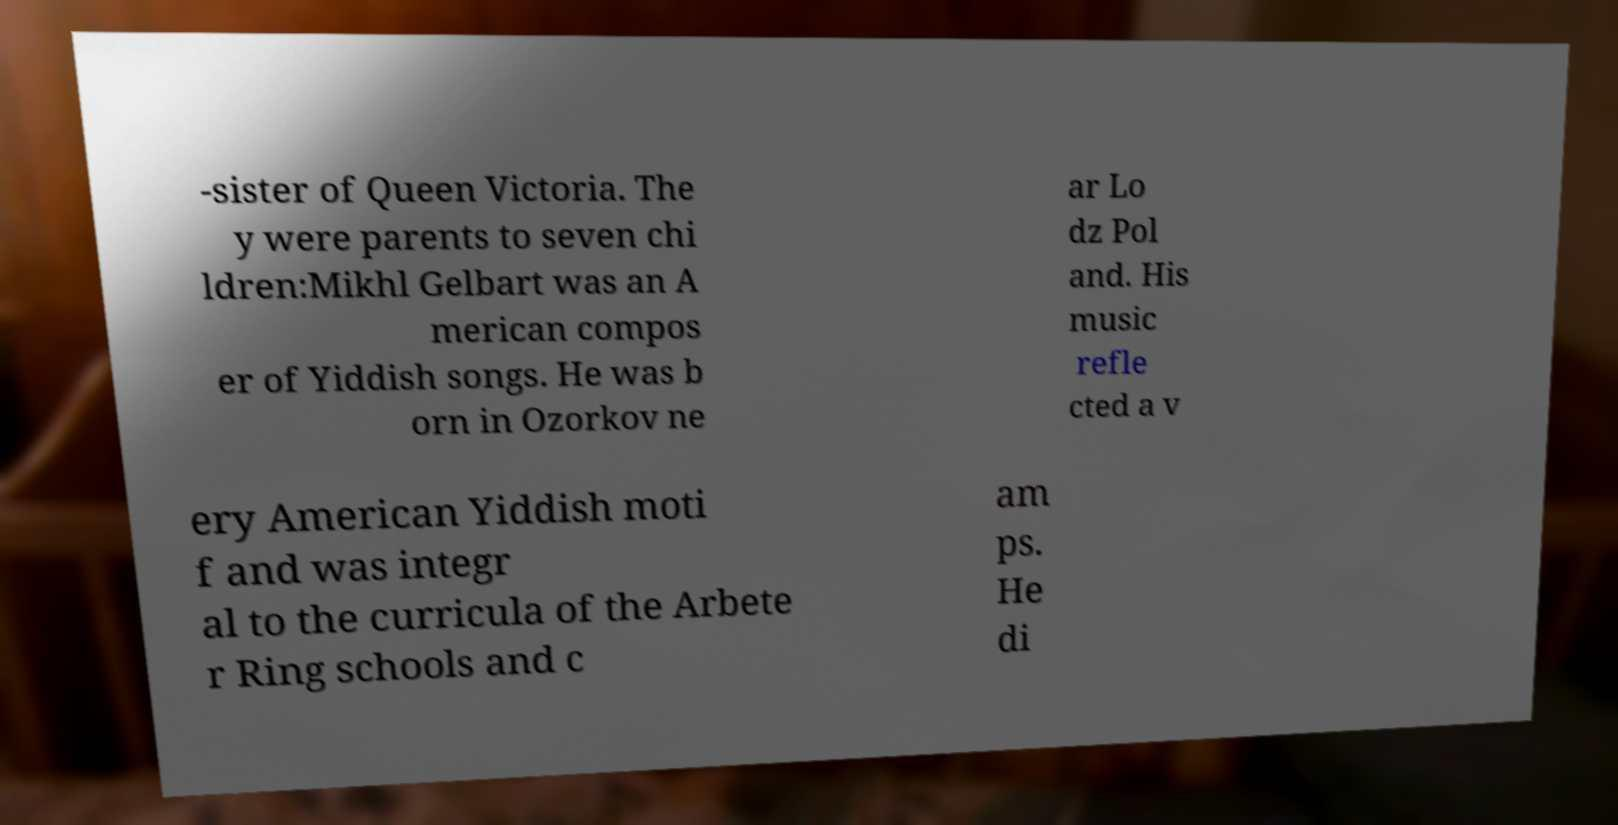Can you read and provide the text displayed in the image?This photo seems to have some interesting text. Can you extract and type it out for me? -sister of Queen Victoria. The y were parents to seven chi ldren:Mikhl Gelbart was an A merican compos er of Yiddish songs. He was b orn in Ozorkov ne ar Lo dz Pol and. His music refle cted a v ery American Yiddish moti f and was integr al to the curricula of the Arbete r Ring schools and c am ps. He di 